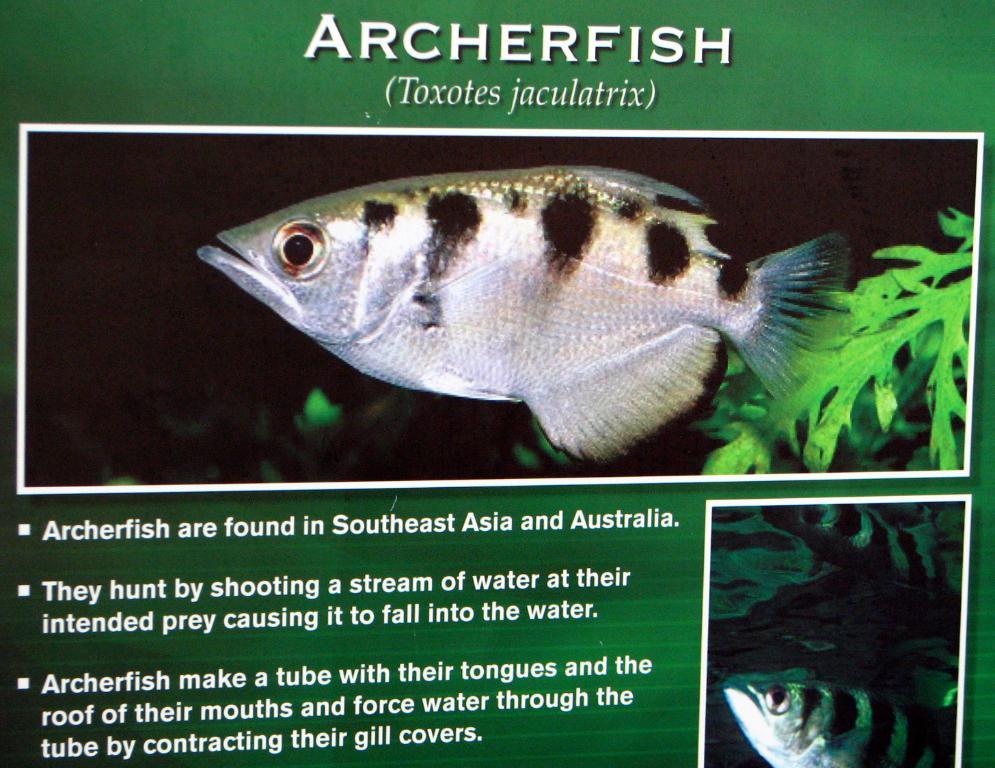Can you describe this image briefly? In this image we can see the information board and a fish picture on it. 